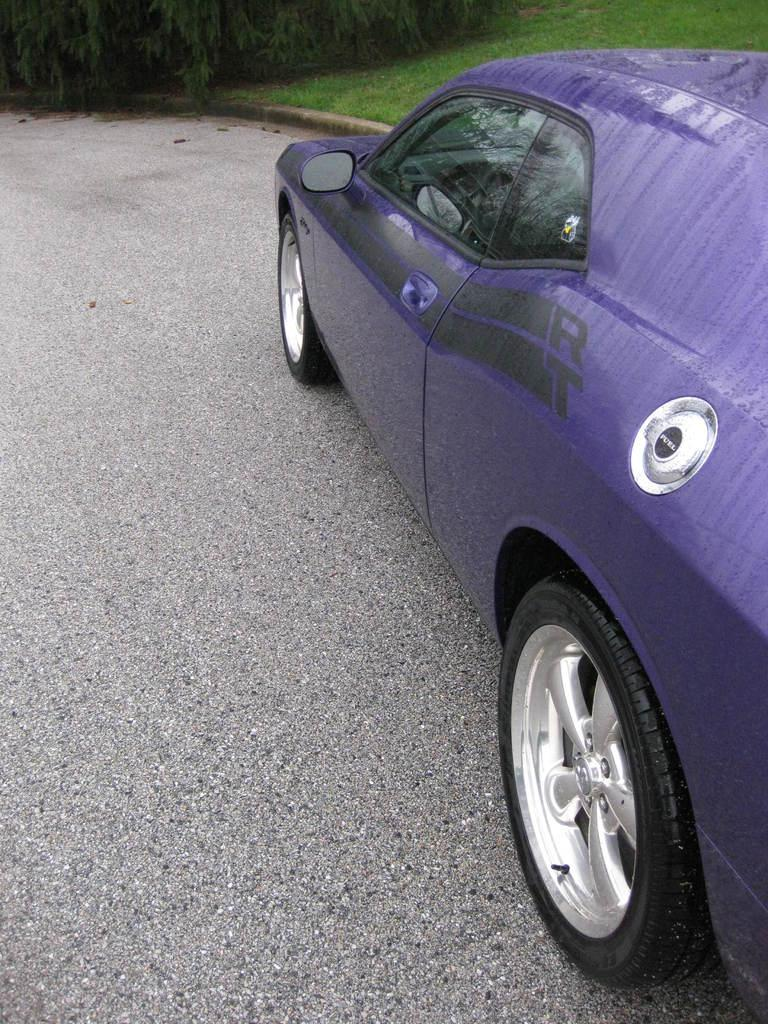What is the main subject of the image? There is a car in the image. What color is the car? The car is blue in color. What is the setting of the image? There is a road and grass visible in the image. What else can be seen in the image besides the car and the road? There are leaves in the image. What type of window is visible in the image? There is no window present in the image; it features a blue car, a road, grass, and leaves. What is the plot of the story being told in the image? The image does not tell a story or have a plot; it is a static representation of a car, road, grass, and leaves. 